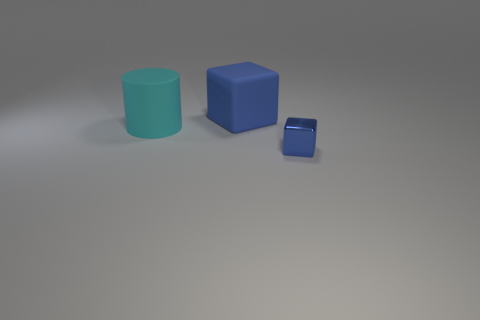There is a rubber object that is on the left side of the blue cube left of the tiny blue thing; what color is it?
Your answer should be compact. Cyan. Is the tiny object made of the same material as the object that is on the left side of the matte block?
Your answer should be very brief. No. What is the color of the rubber object that is in front of the object that is behind the large object that is on the left side of the blue rubber thing?
Your answer should be very brief. Cyan. Is there any other thing that has the same shape as the blue shiny thing?
Keep it short and to the point. Yes. Is the number of large matte cylinders greater than the number of small cyan spheres?
Make the answer very short. Yes. How many large things are both left of the rubber block and to the right of the large cyan matte object?
Make the answer very short. 0. What number of big blue objects are right of the big thing behind the large cyan matte cylinder?
Your answer should be compact. 0. There is a blue object behind the tiny metal cube; is it the same size as the matte object that is on the left side of the big blue cube?
Your answer should be very brief. Yes. What number of blue matte things are there?
Make the answer very short. 1. How many big cyan cylinders are made of the same material as the big block?
Provide a short and direct response. 1. 